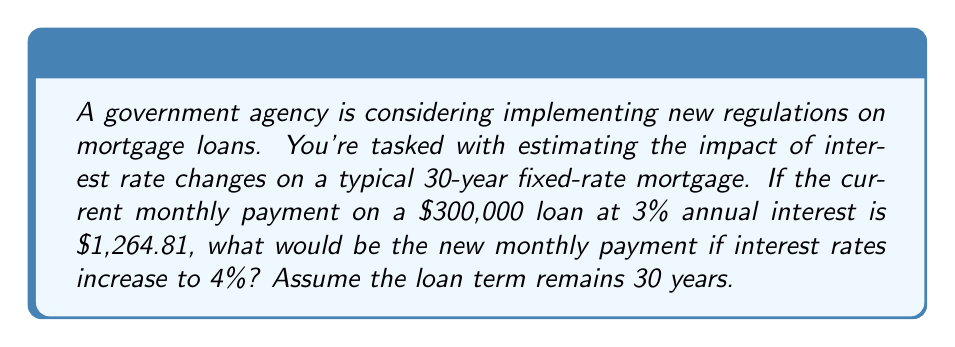Show me your answer to this math problem. To solve this problem, we'll use the mortgage payment formula and calculate the new payment with the increased interest rate. Here's the step-by-step process:

1. The mortgage payment formula is:

   $$P = L \frac{r(1+r)^n}{(1+r)^n - 1}$$

   Where:
   $P$ = monthly payment
   $L$ = loan amount
   $r$ = monthly interest rate (annual rate divided by 12)
   $n$ = total number of months (years * 12)

2. We're given:
   $L = 300,000$
   $n = 30 * 12 = 360$ months

3. For the new interest rate:
   Annual rate = 4% = 0.04
   Monthly rate = $r = \frac{0.04}{12} = 0.003333$

4. Plug these values into the formula:

   $$P = 300,000 \frac{0.003333(1+0.003333)^{360}}{(1+0.003333)^{360} - 1}$$

5. Using a calculator or spreadsheet to compute this:

   $$P = 300,000 * 0.004774$$
   $$P = 1,432.25$$

6. Round to the nearest cent:
   The new monthly payment would be $1,432.25.

7. To calculate the difference:
   $1,432.25 - 1,264.81 = 167.44$

The monthly payment increased by $167.44 due to the 1% rise in interest rates.
Answer: $1,432.25 